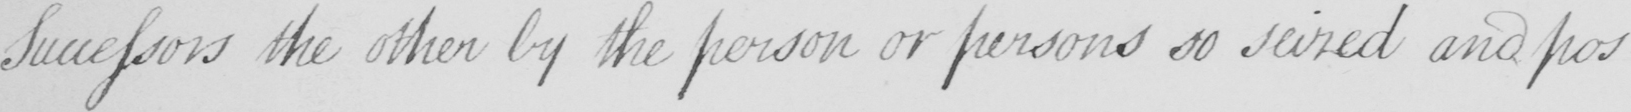Can you tell me what this handwritten text says? Successors the other by the person or persons so seized and pos- 